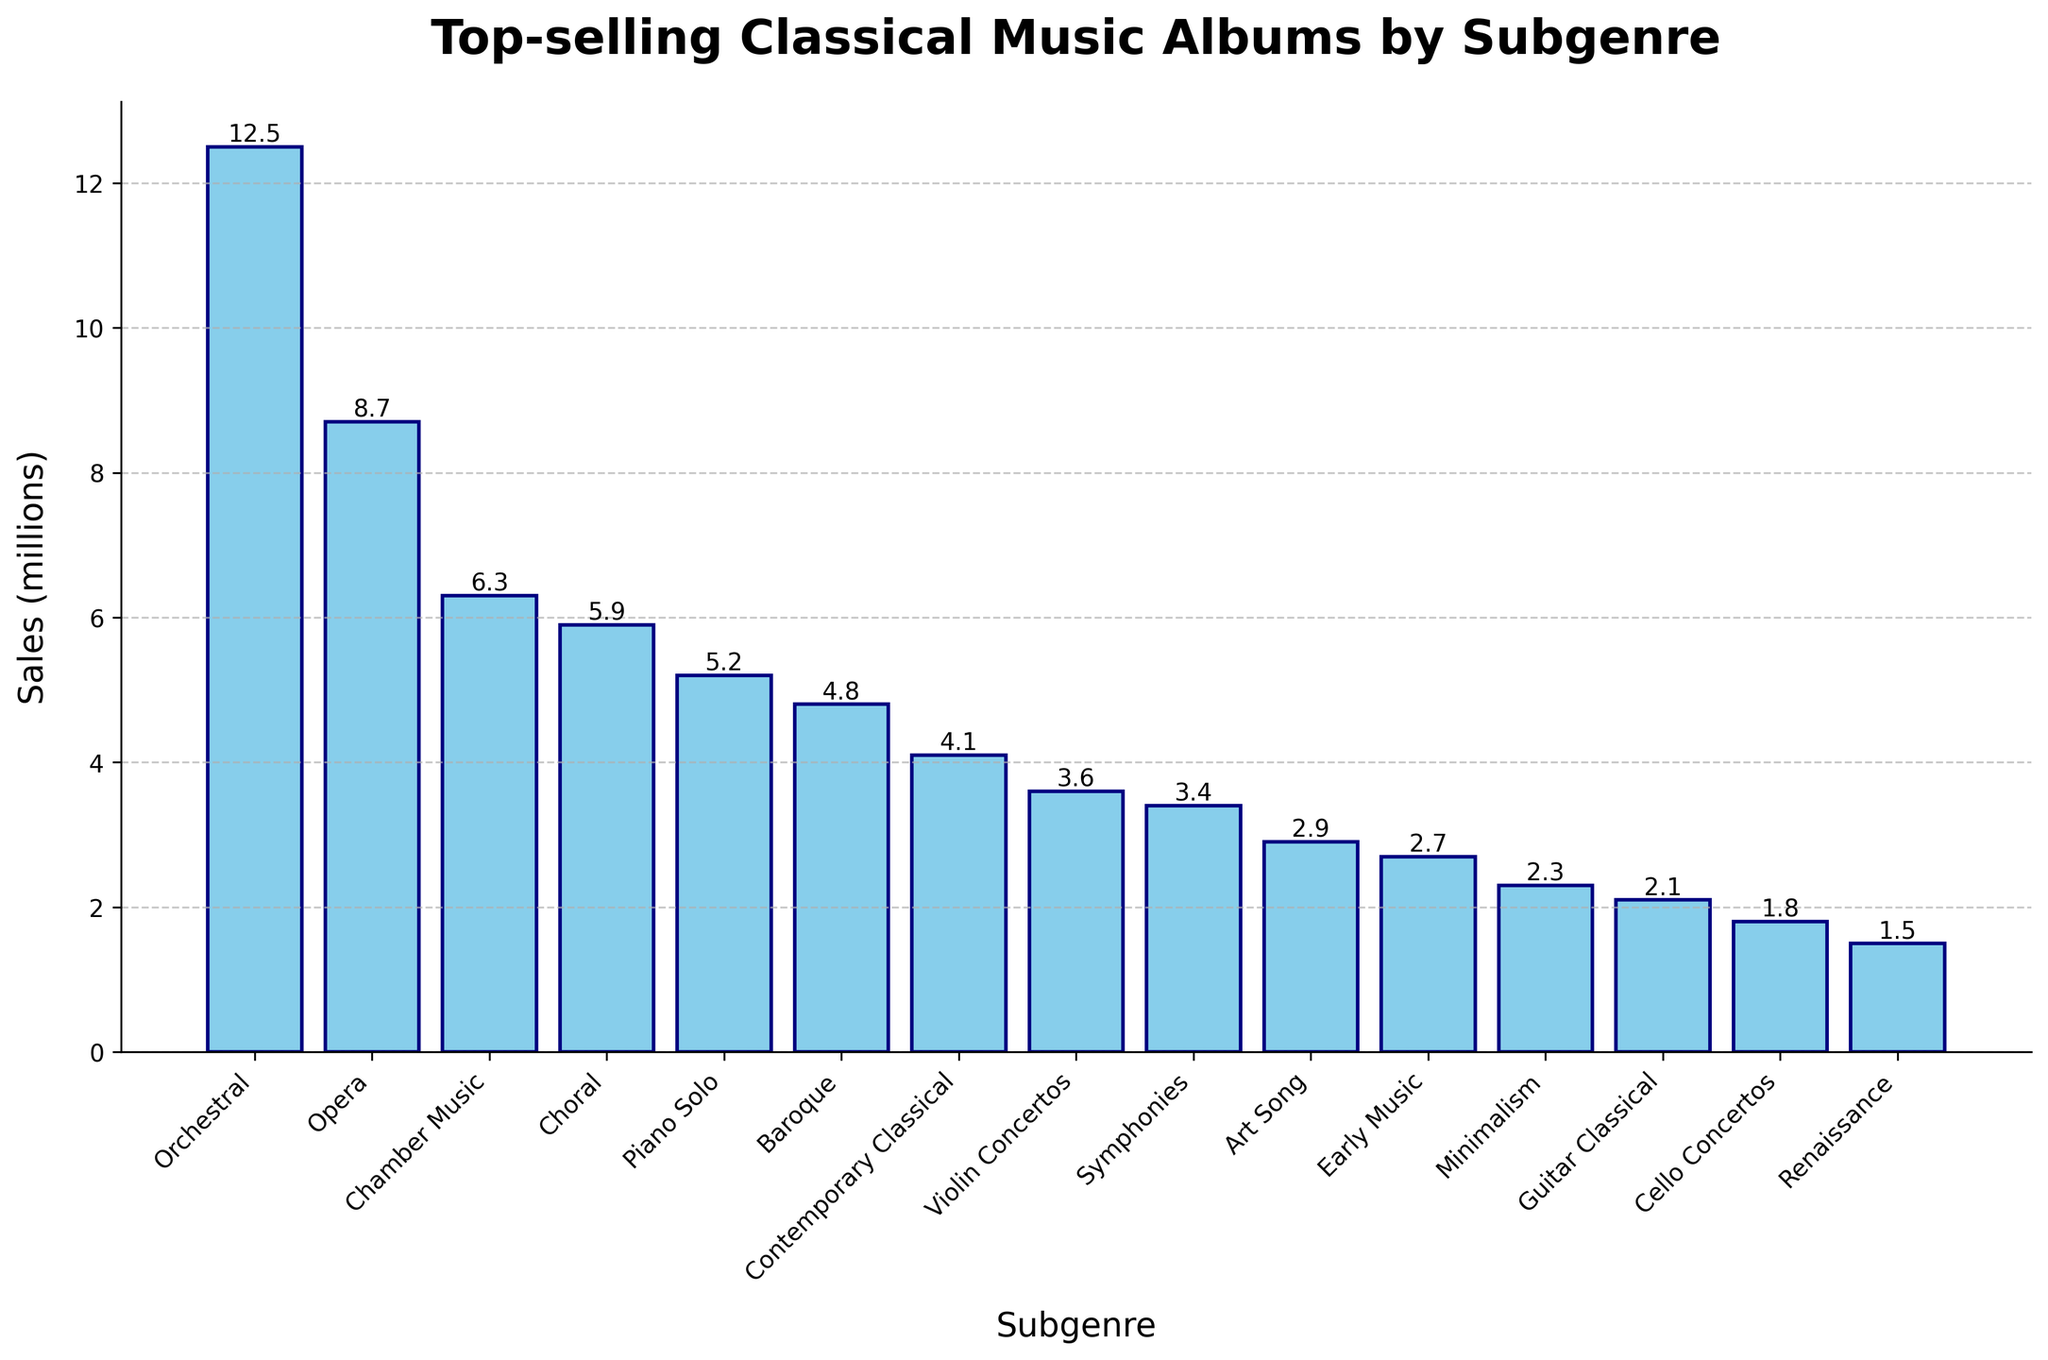What's the best-selling subgenre of classical music albums in the past decade? Look at the bar chart and identify which bar is the tallest. The subgenre with the tallest bar represents the best-selling subgenre.
Answer: Orchestral Which subgenre sold the least number of albums? Locate the shortest bar in the bar chart. The subgenre associated with the shortest bar signifies the one with the least sales.
Answer: Renaissance How much more did Orchestral albums sell compared to Piano Solo albums? Find the heights (sales) of the Orchestral and Piano Solo bars, then subtract the sales of Piano Solo from Orchestral. Orchestral (12.5 millions) - Piano Solo (5.2 millions) = 7.3 millions
Answer: 7.3 millions What is the total sales of Orchestral and Opera subgenres combined? Find the sales of both Orchestral and Opera subgenres and sum them up. Orchestral (12.5 millions) + Opera (8.7 millions) = 21.2 millions
Answer: 21.2 millions How many subgenres sold more than 5 million albums? Count the bars with heights greater than 5 million. Subgenres with sales above 5 million: Orchestral, Opera, Chamber Music, Choral, Piano Solo. 5 bars in total.
Answer: 5 Do Choral albums have higher sales than Baroque albums? Compare the heights of the Choral and Baroque bars. Choral (5.9 millions) is higher than Baroque (4.8 millions).
Answer: Yes What is the average sales of the top three best-selling subgenres? Identify the top three subgenres (Orchestral, Opera, Chamber Music), then calculate the average. (12.5 millions + 8.7 millions + 6.3 millions) / 3 = 9.17 millions
Answer: 9.17 millions Which subgenre is directly to the left of Opera on the x-axis? Look at the bar next to Opera on its left side.
Answer: Orchestral 